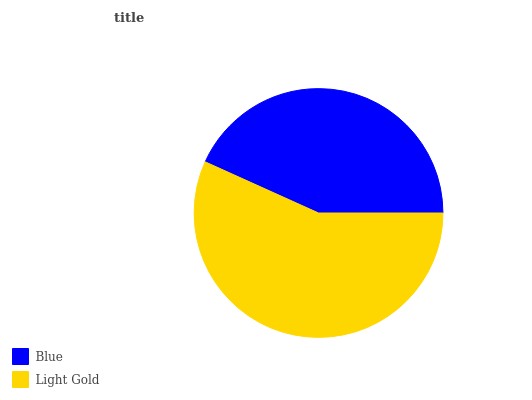Is Blue the minimum?
Answer yes or no. Yes. Is Light Gold the maximum?
Answer yes or no. Yes. Is Light Gold the minimum?
Answer yes or no. No. Is Light Gold greater than Blue?
Answer yes or no. Yes. Is Blue less than Light Gold?
Answer yes or no. Yes. Is Blue greater than Light Gold?
Answer yes or no. No. Is Light Gold less than Blue?
Answer yes or no. No. Is Light Gold the high median?
Answer yes or no. Yes. Is Blue the low median?
Answer yes or no. Yes. Is Blue the high median?
Answer yes or no. No. Is Light Gold the low median?
Answer yes or no. No. 